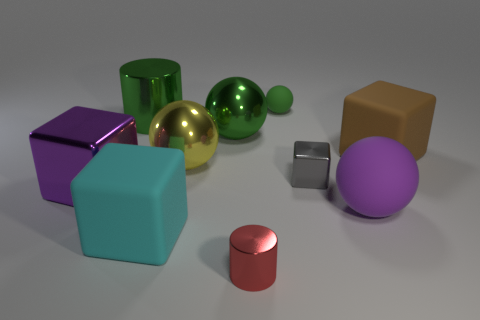There is a brown cube that is the same size as the yellow object; what material is it?
Offer a very short reply. Rubber. What size is the shiny cylinder to the right of the big sphere behind the big cube that is right of the gray metal block?
Offer a very short reply. Small. There is a metal cylinder in front of the purple ball; is there a object that is on the right side of it?
Keep it short and to the point. Yes. Is the shape of the tiny red thing the same as the large green object that is left of the big cyan cube?
Offer a very short reply. Yes. What color is the large cube right of the purple ball?
Your answer should be compact. Brown. How big is the sphere in front of the big purple thing that is to the left of the large green sphere?
Your answer should be compact. Large. There is a big purple thing to the right of the small rubber object; is it the same shape as the yellow thing?
Ensure brevity in your answer.  Yes. What is the material of the other thing that is the same shape as the red metallic object?
Provide a short and direct response. Metal. How many objects are either big metal things that are behind the small gray object or purple objects left of the cyan block?
Your response must be concise. 4. There is a tiny matte thing; is its color the same as the large metallic sphere that is behind the brown matte cube?
Give a very brief answer. Yes. 